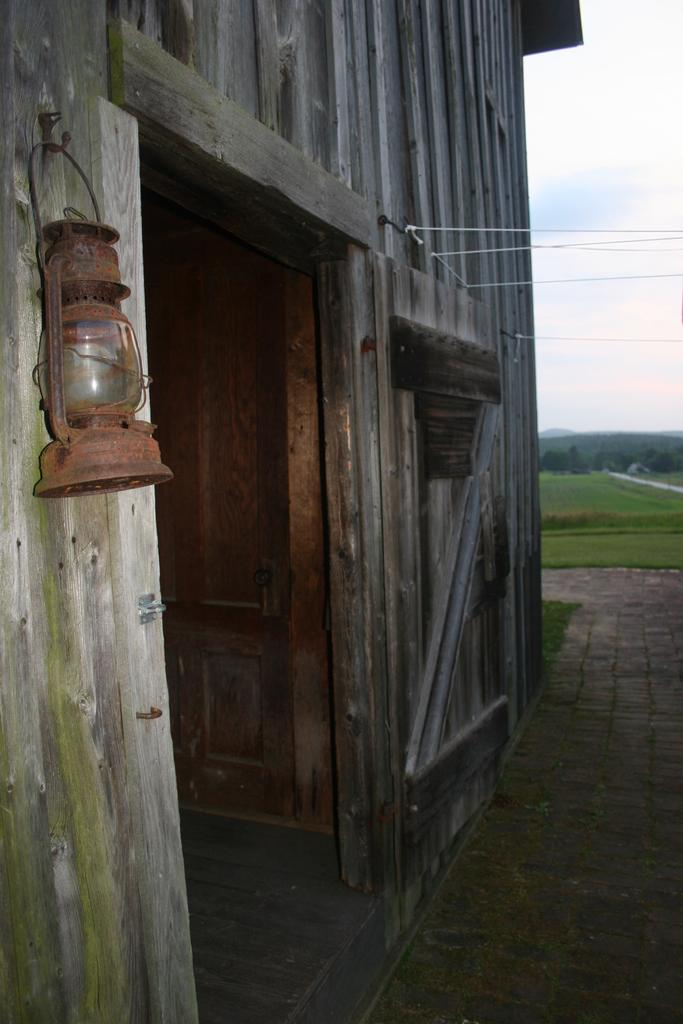What type of structure is present in the image? There is a shed in the image. Can you describe any objects attached to the shed? There is a lamp placed on the wall in the image. What can be seen in the distance behind the shed? Hills are visible in the background of the image. What part of the natural environment is visible in the image? The sky is visible in the background of the image. What type of rose is being used to season the meat in the image? There is no rose or meat present in the image. 